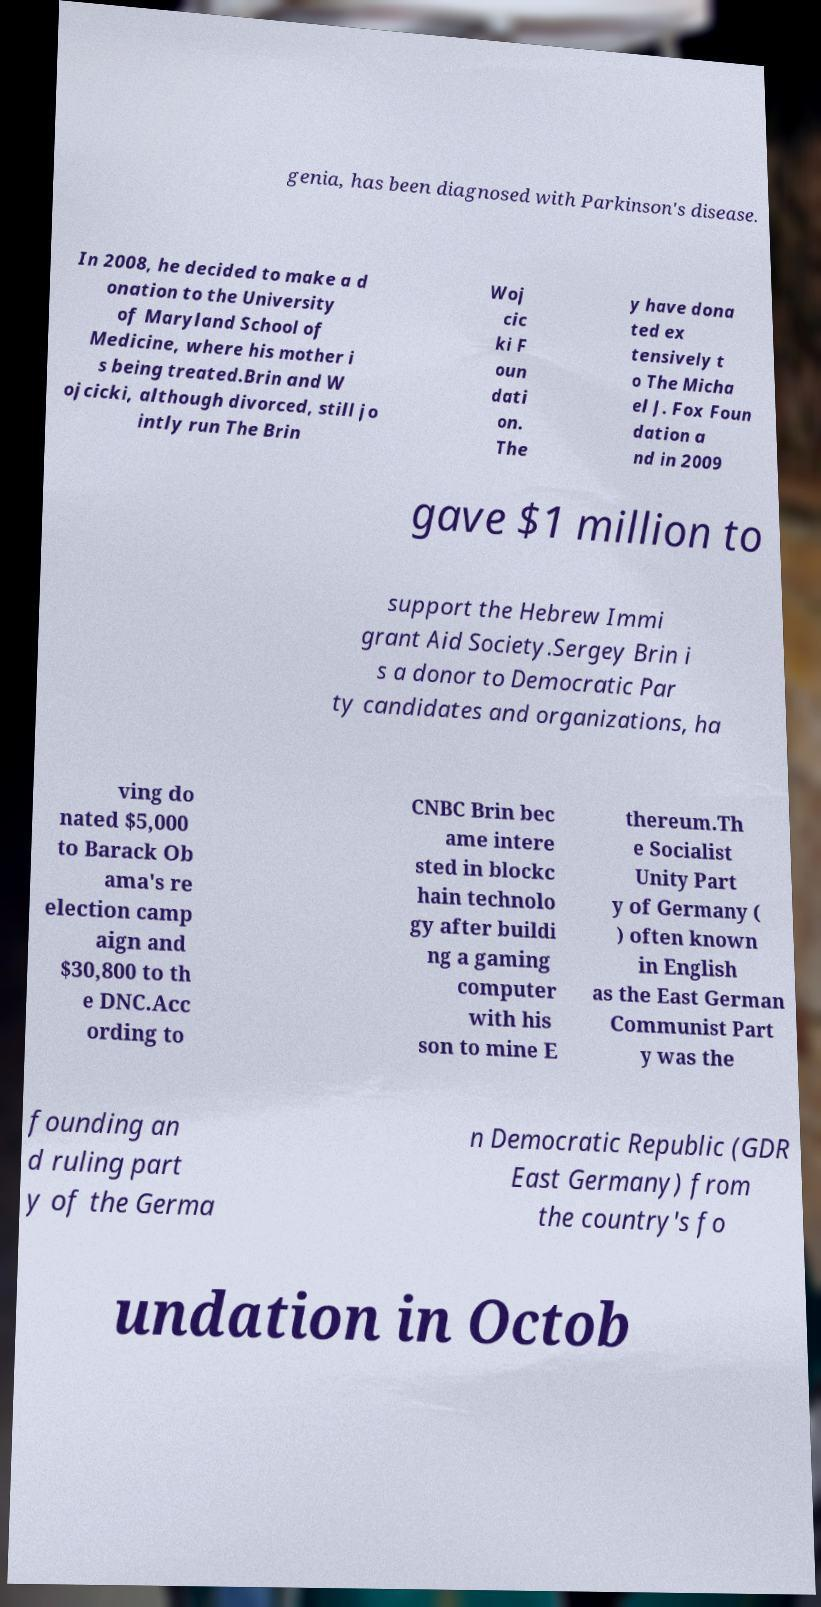Can you read and provide the text displayed in the image?This photo seems to have some interesting text. Can you extract and type it out for me? genia, has been diagnosed with Parkinson's disease. In 2008, he decided to make a d onation to the University of Maryland School of Medicine, where his mother i s being treated.Brin and W ojcicki, although divorced, still jo intly run The Brin Woj cic ki F oun dati on. The y have dona ted ex tensively t o The Micha el J. Fox Foun dation a nd in 2009 gave $1 million to support the Hebrew Immi grant Aid Society.Sergey Brin i s a donor to Democratic Par ty candidates and organizations, ha ving do nated $5,000 to Barack Ob ama's re election camp aign and $30,800 to th e DNC.Acc ording to CNBC Brin bec ame intere sted in blockc hain technolo gy after buildi ng a gaming computer with his son to mine E thereum.Th e Socialist Unity Part y of Germany ( ) often known in English as the East German Communist Part y was the founding an d ruling part y of the Germa n Democratic Republic (GDR East Germany) from the country's fo undation in Octob 